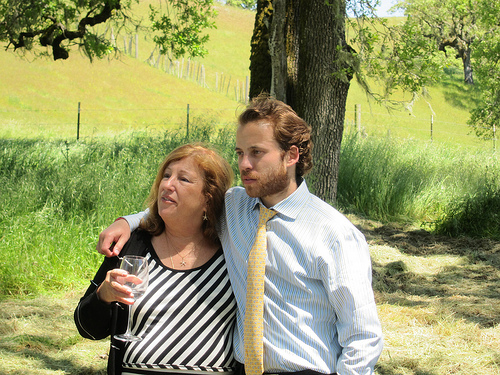<image>
Can you confirm if the top is on the man? No. The top is not positioned on the man. They may be near each other, but the top is not supported by or resting on top of the man. 